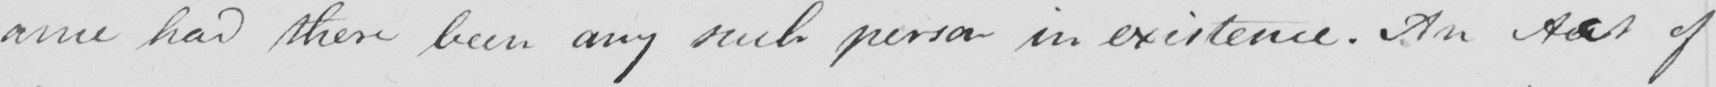Can you read and transcribe this handwriting? -ance had there been any such person in existence . An Acct of 